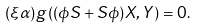<formula> <loc_0><loc_0><loc_500><loc_500>( \xi \alpha ) g \left ( ( \phi S + S \phi ) X , Y \right ) = 0 .</formula> 